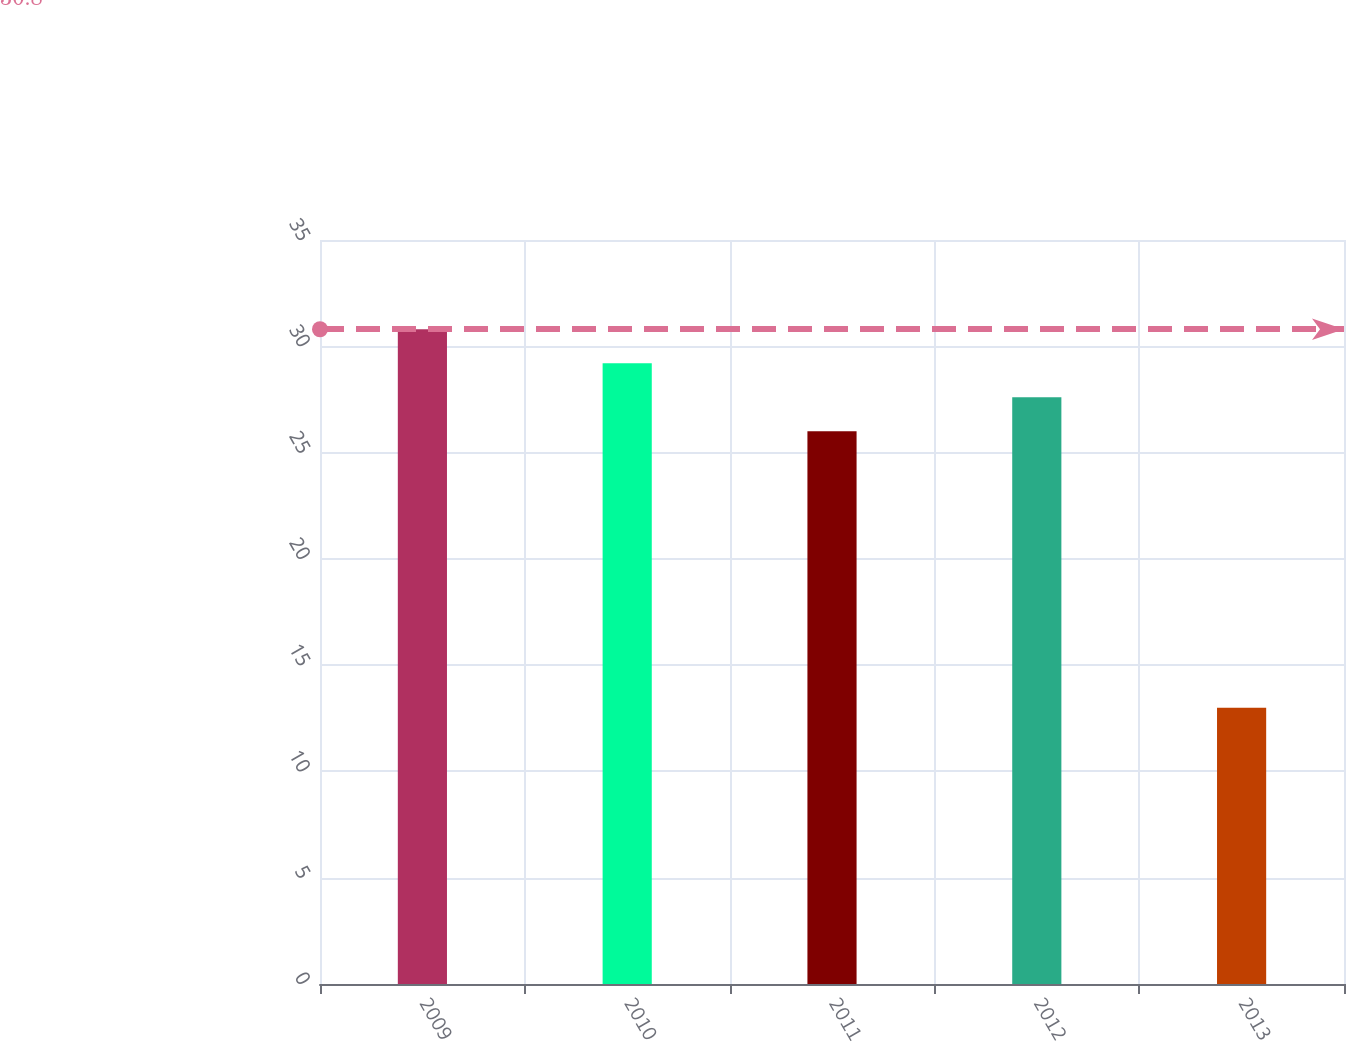Convert chart to OTSL. <chart><loc_0><loc_0><loc_500><loc_500><bar_chart><fcel>2009<fcel>2010<fcel>2011<fcel>2012<fcel>2013<nl><fcel>30.8<fcel>29.2<fcel>26<fcel>27.6<fcel>13<nl></chart> 